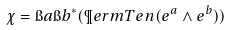Convert formula to latex. <formula><loc_0><loc_0><loc_500><loc_500>\chi = \i a \i b ^ { * } ( \P e r m T e n ( e ^ { a } \wedge e ^ { b } ) )</formula> 